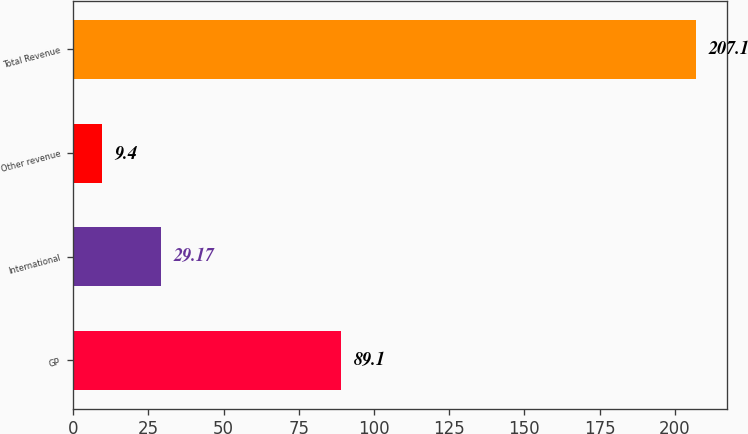Convert chart to OTSL. <chart><loc_0><loc_0><loc_500><loc_500><bar_chart><fcel>GP<fcel>International<fcel>Other revenue<fcel>Total Revenue<nl><fcel>89.1<fcel>29.17<fcel>9.4<fcel>207.1<nl></chart> 